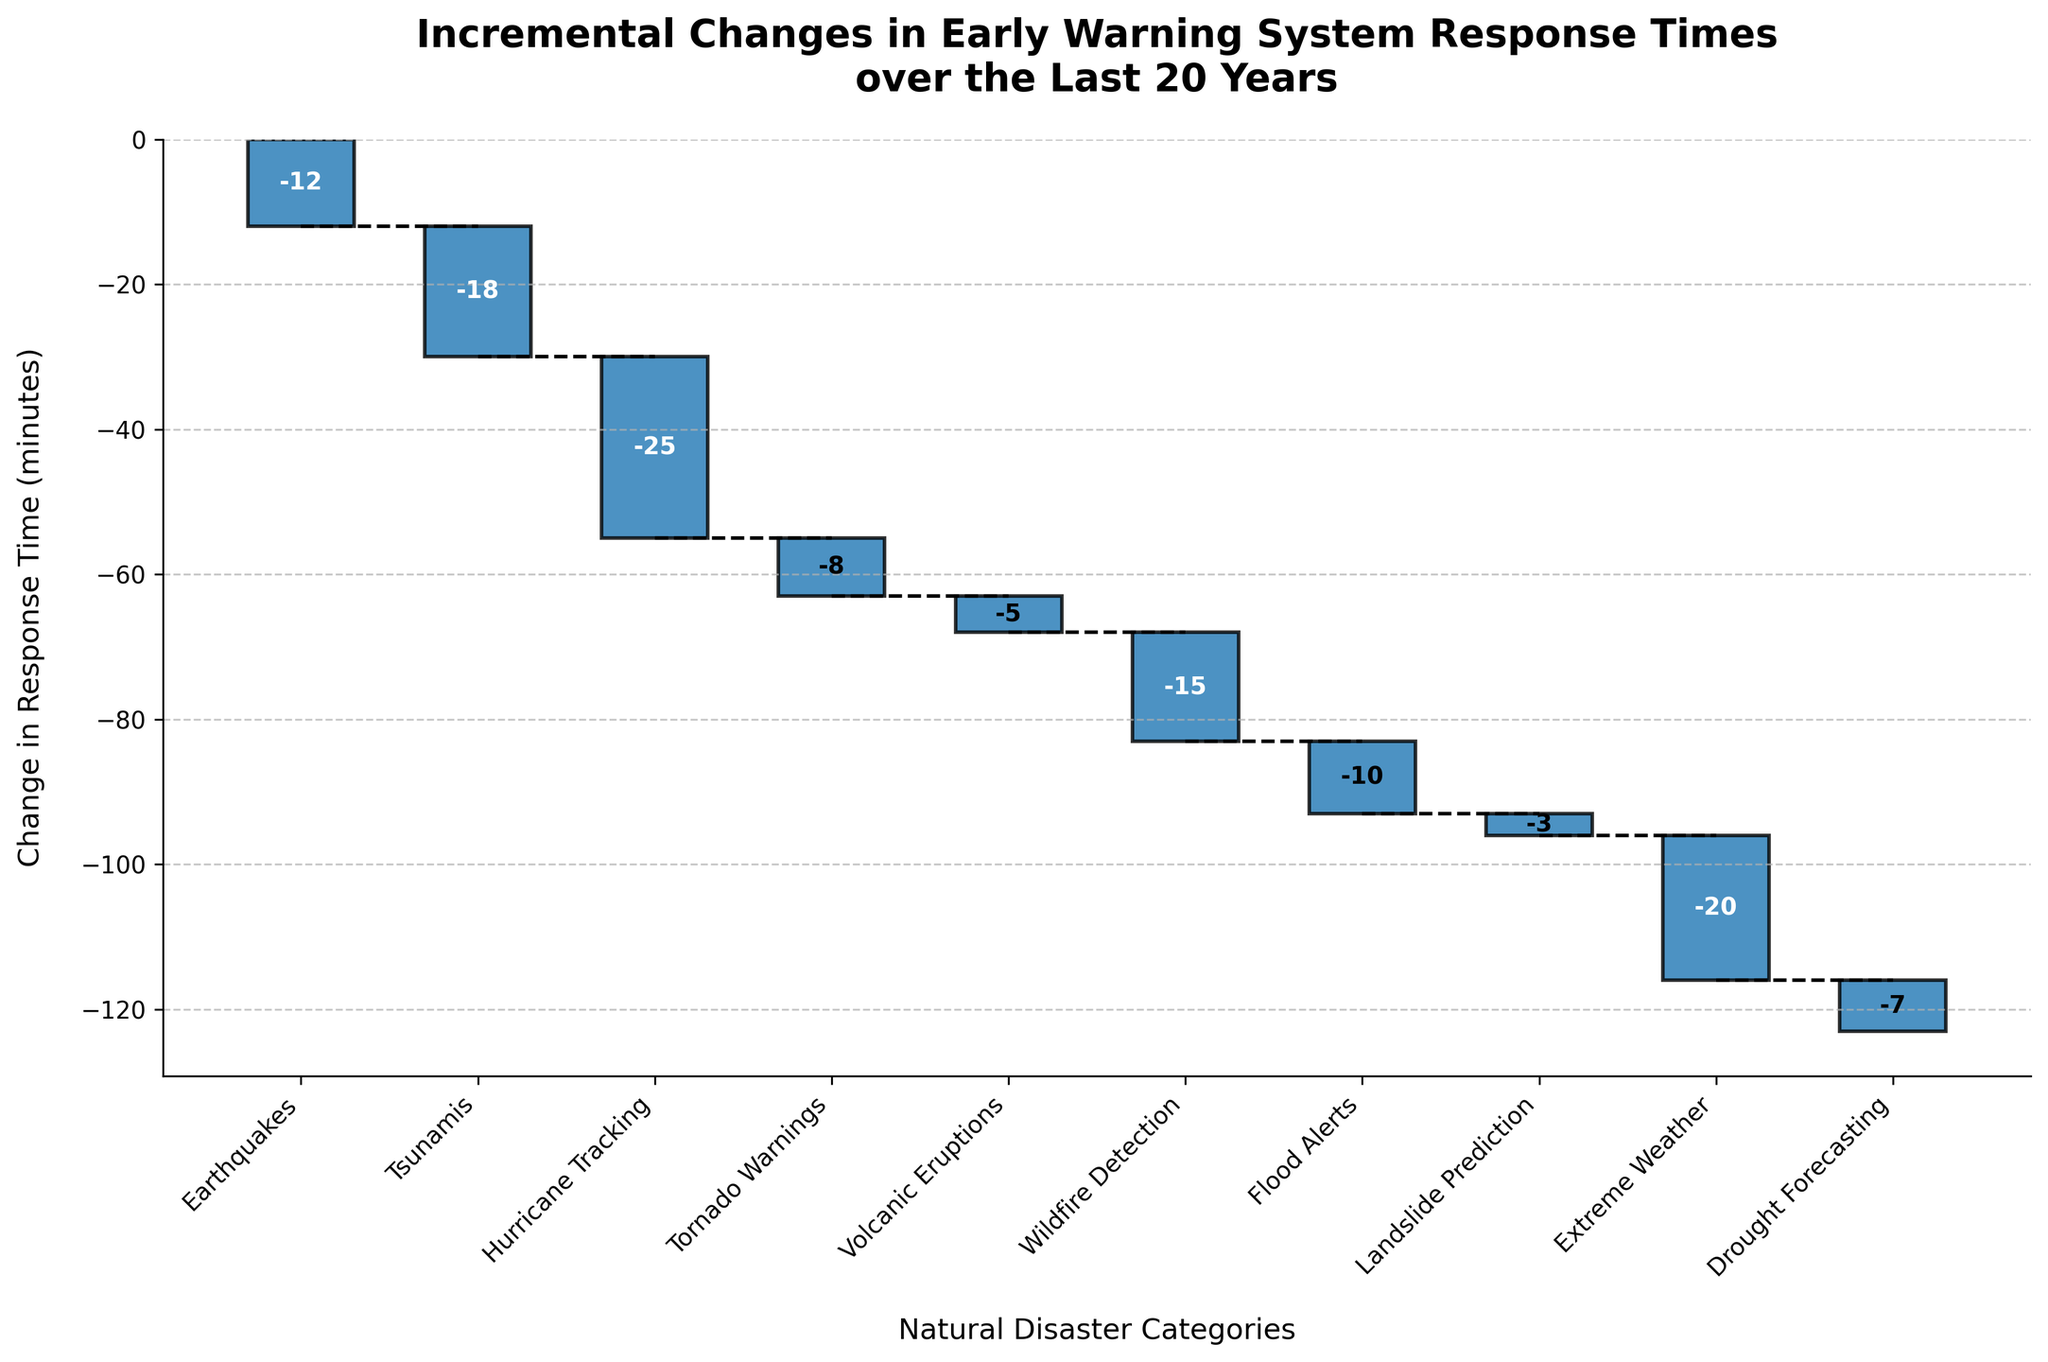What is the title of the chart? The title of the chart is typically found at the top and provides an overview of what the chart is about.
Answer: Incremental Changes in Early Warning System Response Times over the Last 20 Years What color is used to represent the decreases in response times? The color can be observed in the bars that show a negative change in response time.
Answer: Blue Which category has the greatest reduction in response time? To find the category with the greatest reduction, look for the bar that extends the most downwards.
Answer: Hurricane Tracking By how many minutes has tsunami warning response time improved? The improvement in response time for tsunami warnings can be directly read from the corresponding bar.
Answer: 18 minutes What is the total improvement in response time for Earthquakes, Tsunamis, and Hurricane Tracking combined? Sum the changes in response time for these three categories: -12 + -18 + -25.
Answer: 55 minutes Which category shows the least reduction in response time? Look for the bar that shows the smallest decrease; this corresponds to the least improvement.
Answer: Landslide Prediction How many categories show a reduction in response time greater than 10 minutes? Count the number of bars that extend more than 10 units downward.
Answer: 6 categories What is the average change in response time across all categories? First, sum all the changes and then divide by the number of categories. (-12 + -18 + -25 + -8 + -5 + -15 + -10 + -3 + -20 + -7) / 10 = -123 / 10
Answer: -12.3 minutes Which two categories have combined reductions close to 30 minutes? Identify pairs of categories whose sum of changes is approximately -30 minutes, such as Extreme Weather (-20) and Drought Forecasting (-7) resulting in -27.
Answer: Extreme Weather and Drought Forecasting What is the cumulative change in response time after incorporating the first three categories (Earthquakes, Tsunamis, and Hurricane Tracking)? Calculate the cumulative sum of the changes for these categories: -12 + -18 + -25 = -55.
Answer: 55 minutes 